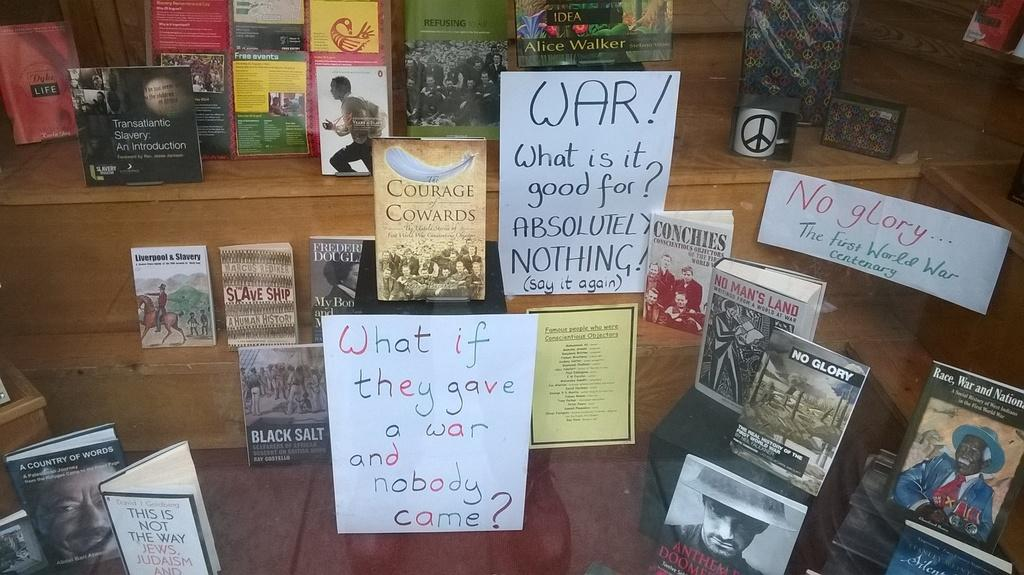<image>
Summarize the visual content of the image. A handwritten sign on display with some books reads "What if they gave a war and nobody came?" 